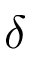Convert formula to latex. <formula><loc_0><loc_0><loc_500><loc_500>\delta</formula> 